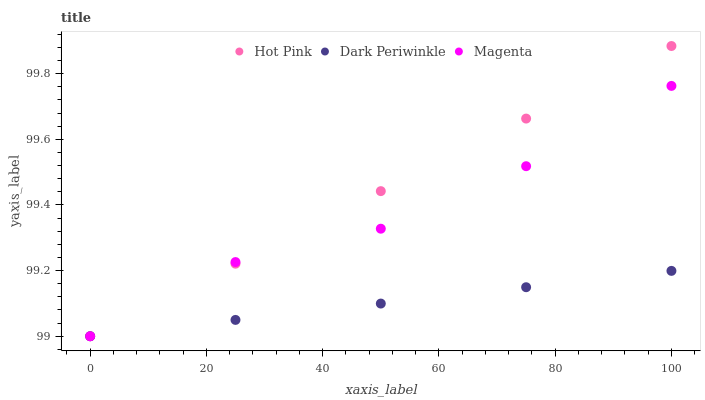Does Dark Periwinkle have the minimum area under the curve?
Answer yes or no. Yes. Does Hot Pink have the maximum area under the curve?
Answer yes or no. Yes. Does Hot Pink have the minimum area under the curve?
Answer yes or no. No. Does Dark Periwinkle have the maximum area under the curve?
Answer yes or no. No. Is Dark Periwinkle the smoothest?
Answer yes or no. Yes. Is Magenta the roughest?
Answer yes or no. Yes. Is Hot Pink the smoothest?
Answer yes or no. No. Is Hot Pink the roughest?
Answer yes or no. No. Does Magenta have the lowest value?
Answer yes or no. Yes. Does Hot Pink have the highest value?
Answer yes or no. Yes. Does Dark Periwinkle have the highest value?
Answer yes or no. No. Does Hot Pink intersect Magenta?
Answer yes or no. Yes. Is Hot Pink less than Magenta?
Answer yes or no. No. Is Hot Pink greater than Magenta?
Answer yes or no. No. 